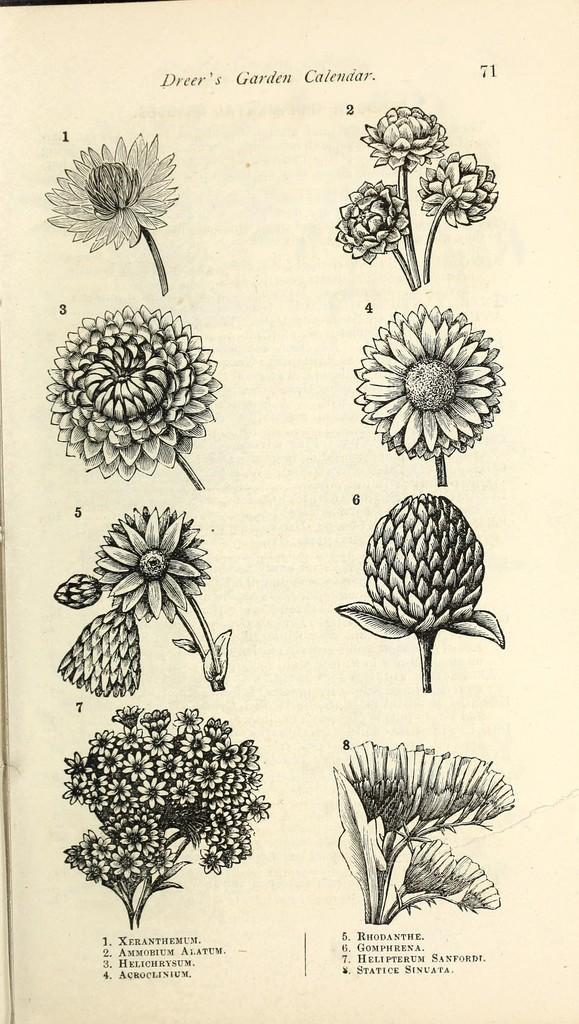Please provide a concise description of this image. In this image, we can see a photo, in that photo we can see some flowers. 